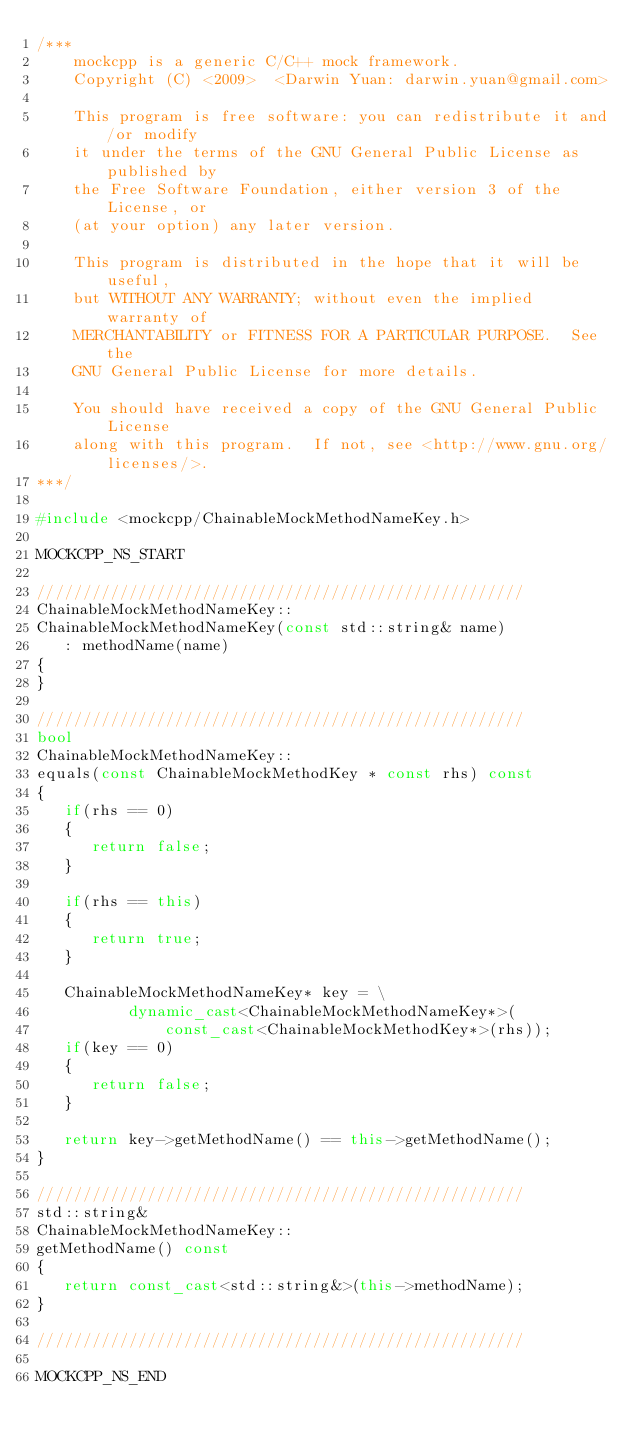<code> <loc_0><loc_0><loc_500><loc_500><_C++_>/***
    mockcpp is a generic C/C++ mock framework.
    Copyright (C) <2009>  <Darwin Yuan: darwin.yuan@gmail.com>

    This program is free software: you can redistribute it and/or modify
    it under the terms of the GNU General Public License as published by
    the Free Software Foundation, either version 3 of the License, or
    (at your option) any later version.

    This program is distributed in the hope that it will be useful,
    but WITHOUT ANY WARRANTY; without even the implied warranty of
    MERCHANTABILITY or FITNESS FOR A PARTICULAR PURPOSE.  See the
    GNU General Public License for more details.

    You should have received a copy of the GNU General Public License
    along with this program.  If not, see <http://www.gnu.org/licenses/>.
***/

#include <mockcpp/ChainableMockMethodNameKey.h>

MOCKCPP_NS_START

/////////////////////////////////////////////////////
ChainableMockMethodNameKey::
ChainableMockMethodNameKey(const std::string& name)
   : methodName(name)
{
}

/////////////////////////////////////////////////////
bool
ChainableMockMethodNameKey::
equals(const ChainableMockMethodKey * const rhs) const
{
   if(rhs == 0)
   {
      return false;
   }

   if(rhs == this)
   {
      return true;
   }

   ChainableMockMethodNameKey* key = \
          dynamic_cast<ChainableMockMethodNameKey*>(
              const_cast<ChainableMockMethodKey*>(rhs));
   if(key == 0)
   {
      return false;
   }
   
   return key->getMethodName() == this->getMethodName();
}

/////////////////////////////////////////////////////
std::string&
ChainableMockMethodNameKey::
getMethodName() const
{
   return const_cast<std::string&>(this->methodName);
}

/////////////////////////////////////////////////////

MOCKCPP_NS_END

</code> 